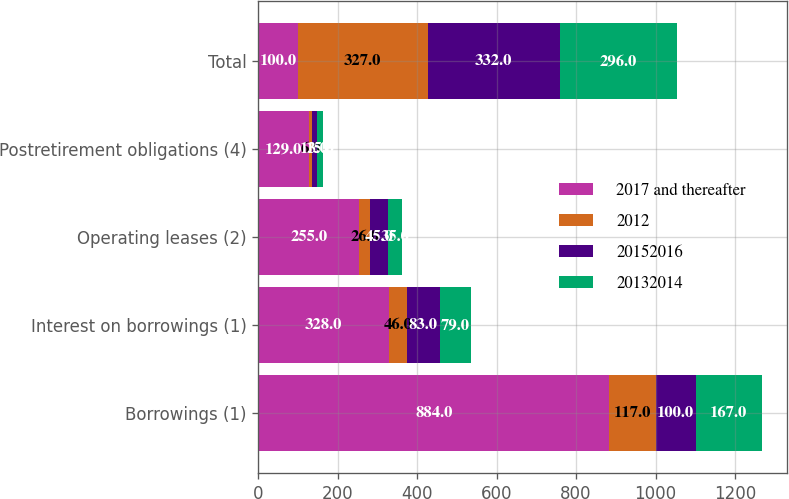Convert chart to OTSL. <chart><loc_0><loc_0><loc_500><loc_500><stacked_bar_chart><ecel><fcel>Borrowings (1)<fcel>Interest on borrowings (1)<fcel>Operating leases (2)<fcel>Postretirement obligations (4)<fcel>Total<nl><fcel>2017 and thereafter<fcel>884<fcel>328<fcel>255<fcel>129<fcel>100<nl><fcel>2012<fcel>117<fcel>46<fcel>26<fcel>6<fcel>327<nl><fcel>20152016<fcel>100<fcel>83<fcel>45<fcel>13<fcel>332<nl><fcel>20132014<fcel>167<fcel>79<fcel>35<fcel>15<fcel>296<nl></chart> 